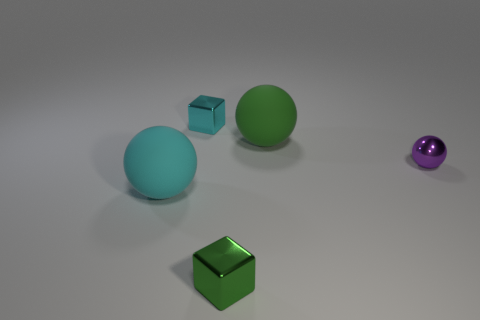What shape is the small purple object?
Give a very brief answer. Sphere. How many things are either large rubber spheres behind the small purple object or small shiny spheres?
Your response must be concise. 2. The other ball that is made of the same material as the green sphere is what size?
Give a very brief answer. Large. Are there more cubes behind the purple thing than large purple rubber cubes?
Ensure brevity in your answer.  Yes. Does the purple object have the same shape as the big thing that is in front of the green ball?
Give a very brief answer. Yes. What number of big objects are metallic balls or red rubber cylinders?
Your answer should be very brief. 0. There is a ball on the left side of the big rubber thing that is to the right of the cyan metal thing; what is its color?
Make the answer very short. Cyan. Do the cyan sphere and the block that is in front of the small cyan shiny cube have the same material?
Provide a short and direct response. No. There is a tiny object right of the big green sphere; what material is it?
Offer a terse response. Metal. Are there an equal number of purple metallic objects that are behind the tiny purple metal sphere and large gray matte blocks?
Offer a terse response. Yes. 